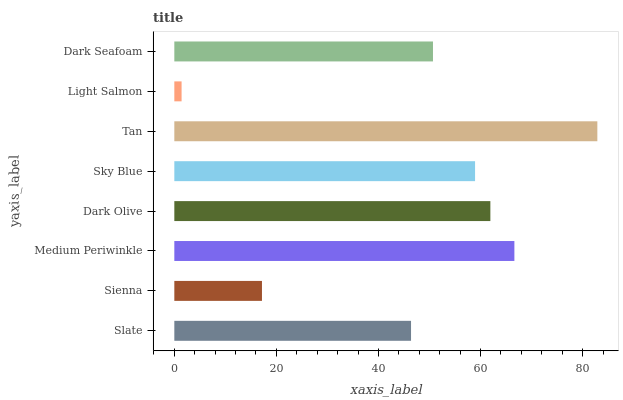Is Light Salmon the minimum?
Answer yes or no. Yes. Is Tan the maximum?
Answer yes or no. Yes. Is Sienna the minimum?
Answer yes or no. No. Is Sienna the maximum?
Answer yes or no. No. Is Slate greater than Sienna?
Answer yes or no. Yes. Is Sienna less than Slate?
Answer yes or no. Yes. Is Sienna greater than Slate?
Answer yes or no. No. Is Slate less than Sienna?
Answer yes or no. No. Is Sky Blue the high median?
Answer yes or no. Yes. Is Dark Seafoam the low median?
Answer yes or no. Yes. Is Medium Periwinkle the high median?
Answer yes or no. No. Is Sky Blue the low median?
Answer yes or no. No. 